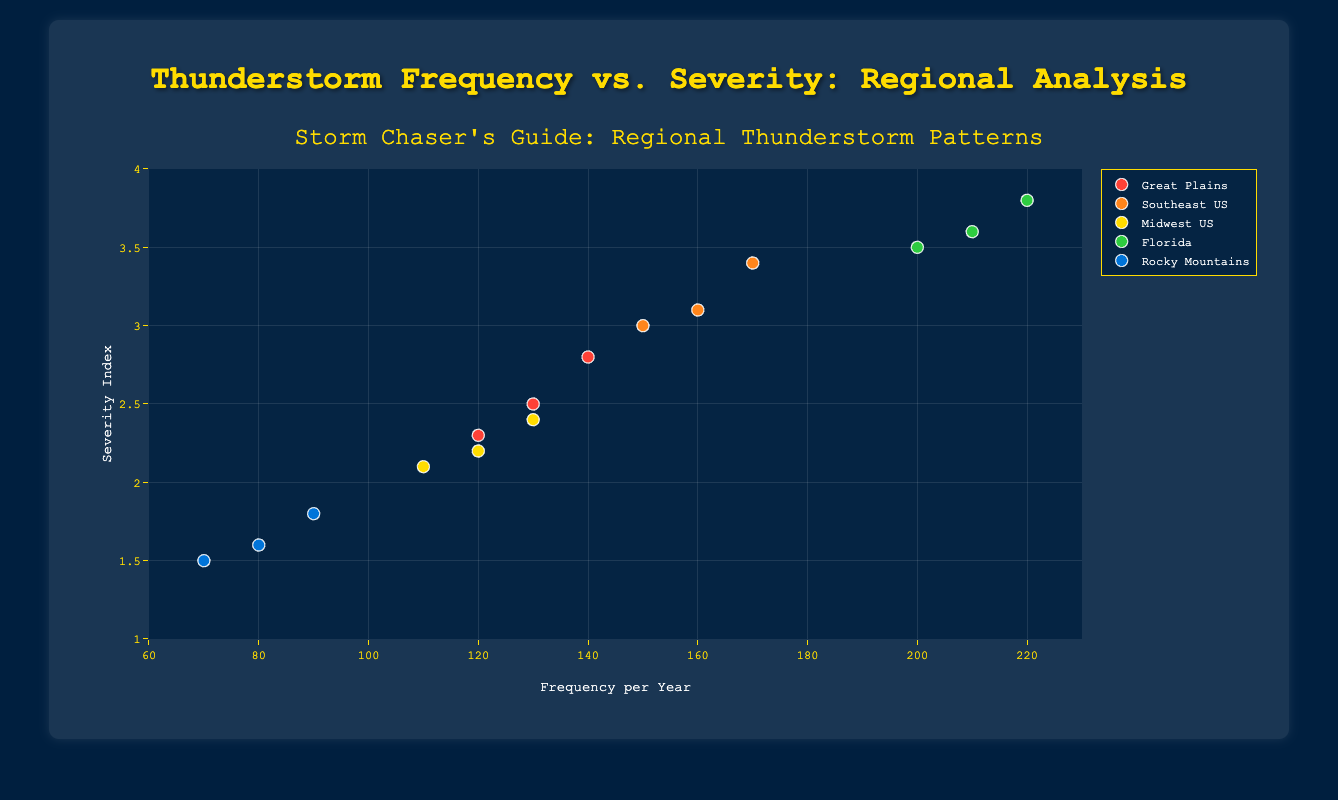What is the x-axis title? The x-axis title can be directly read from the figure. It is located below the horizontal axis, providing information about the data represented.
Answer: Frequency per Year Which region has the data points with the highest severity index? By looking at the highest data points along the y-axis (severity index), we notice that the region named "Florida" has the highest values (3.5, 3.6, 3.8).
Answer: Florida What is the title of the figure? The title of the figure can be found at the top of the chart. It provides a concise summary of what the chart represents.
Answer: Storm Chaser's Guide: Regional Thunderstorm Patterns How many data points are there for the "Midwest US" region? By counting the markers representing the "Midwest US" region in the scatter plot, we find there are 3 data points (110, 120, 130).
Answer: 3 Which region has the lowest average severity index? To determine this, we need to calculate the average severity index for each region and compare them. For "Rocky Mountains," the average severity index is (1.5 + 1.6 + 1.8)/3 = 1.63. No other region has a lower average than 1.63.
Answer: Rocky Mountains What is the frequency range captured in this figure? The frequency range can be found by looking at the minimum and maximum values on the x-axis. The provided x-axis values range from 60 to 230.
Answer: 60 to 230 Which region has the most frequent thunderstorms per year? By comparing the highest frequency values for each region, we find that "Florida" has the highest frequency per year (220).
Answer: Florida What is the relationship between frequency and severity in the "Southeast US" region? By examining the data points for "Southeast US," we observe that as the frequency per year increases (150, 160, 170), the severity index also increases (3.0, 3.1, 3.4).
Answer: Positive correlation Is there a region with data points outside the y-axis range of 1 to 4? By examining the y-axis values for all regions, we confirm that all severity index values fall within the range of 1 to 4.
Answer: No 